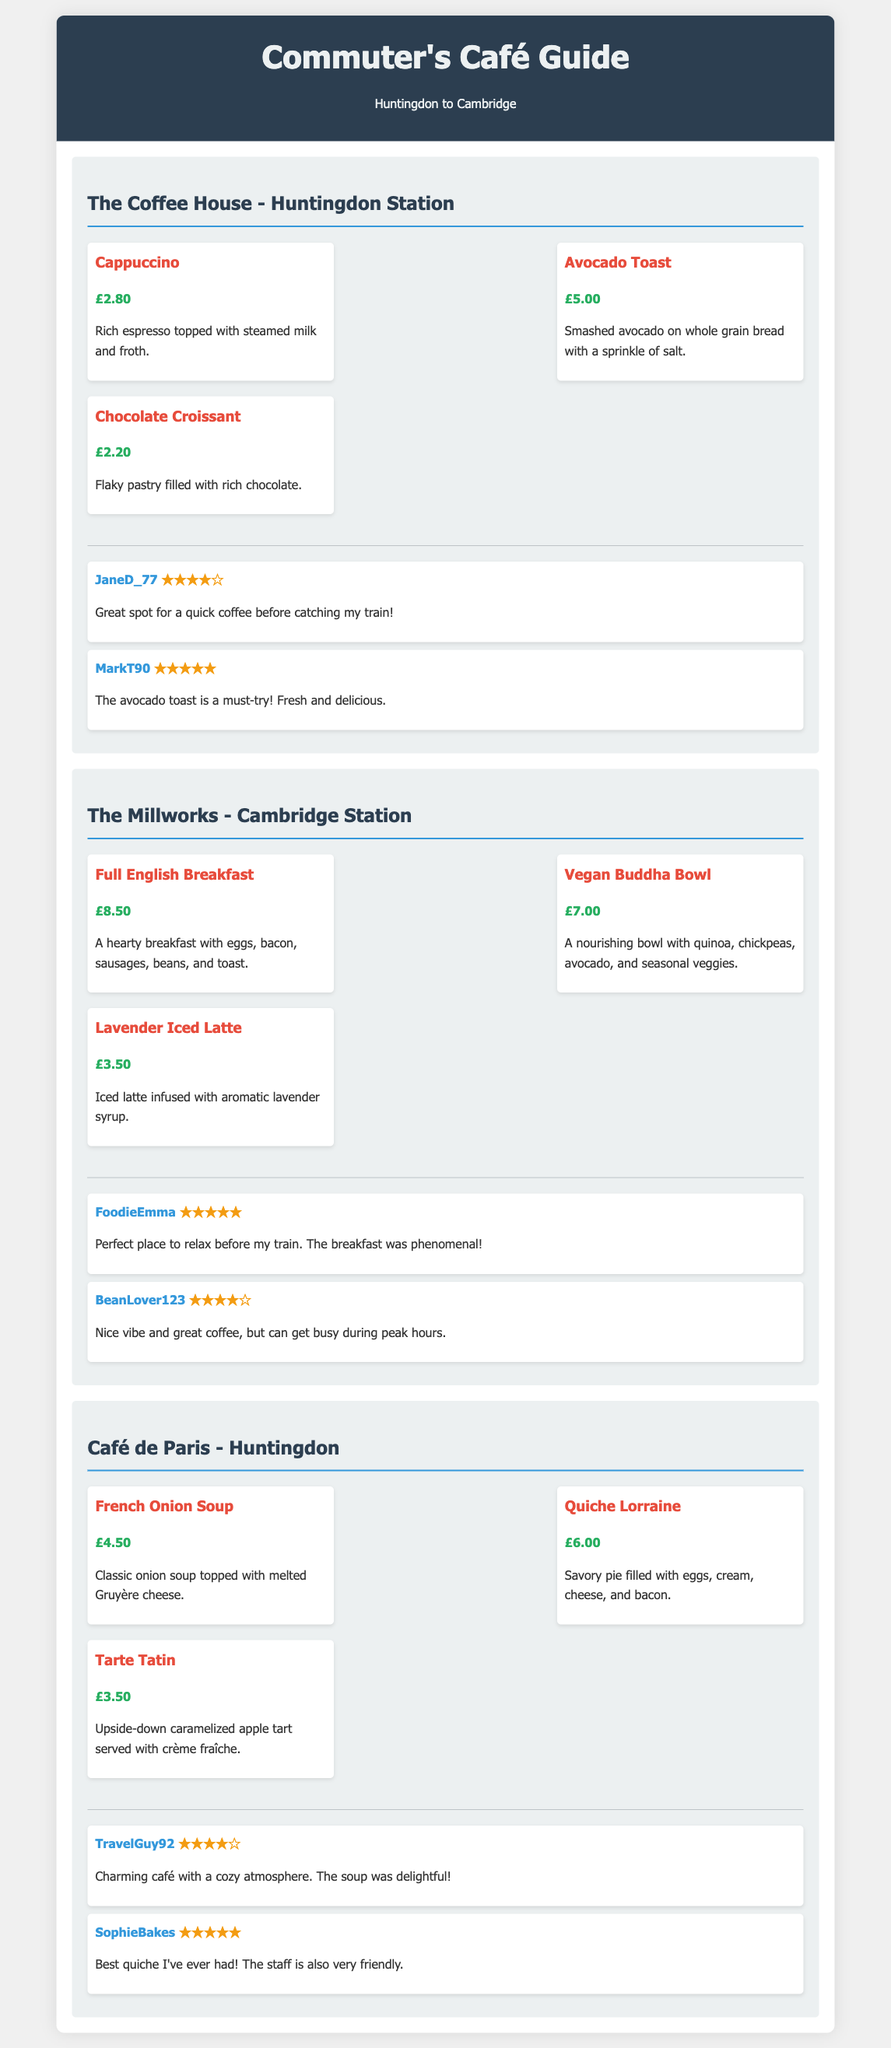What is the name of the café at Huntingdon Station? The café is named "The Coffee House," which provides its location in the title.
Answer: The Coffee House What is the price of a Vegan Buddha Bowl? The price is directly listed next to the menu item under "The Millworks" section.
Answer: £7.00 Which café offers a French Onion Soup? The café that offers it is "Café de Paris," as indicated by the menu items listed.
Answer: Café de Paris How many stars did FoodieEmma rate The Millworks? FoodieEmma's rating is shown next to her review in the list of reviews for The Millworks.
Answer: ★★★★★ What is the main ingredient in the Quiche Lorraine? The description of the Quiche Lorraine provides details about its contents, making it clear what it includes.
Answer: eggs, cream, cheese, and bacon Which café has a menu item that includes caramelized apples? The menu item is Tarte Tatin, which is specifically listed under Café de Paris.
Answer: Café de Paris What type of coffee is priced at £2.80? The menu lists the types of coffee along with their prices; thus, this information can be directly retrieved.
Answer: Cappuccino What is a notable feature of The Coffee House? The reviews highlight the café's reputation for quick service, especially before a train.
Answer: Quick coffee Which café is recommended for a hearty breakfast? The recommendation is derived from the menu offerings and reviews highlighting the breakfast options.
Answer: The Millworks 